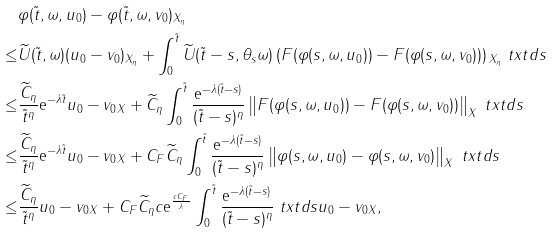Convert formula to latex. <formula><loc_0><loc_0><loc_500><loc_500>& \| \varphi ( \tilde { t } , \omega , u _ { 0 } ) - \varphi ( \tilde { t } , \omega , v _ { 0 } ) \| _ { X _ { \eta } } \\ \leq & \| \widetilde { U } ( \tilde { t } , \omega ) ( u _ { 0 } - v _ { 0 } ) \| _ { X _ { \eta } } + \int _ { 0 } ^ { \tilde { t } } \| \widetilde { U } ( \tilde { t } - s , \theta _ { s } \omega ) \left ( F ( \varphi ( s , \omega , u _ { 0 } ) ) - F ( \varphi ( s , \omega , v _ { 0 } ) ) \right ) \| _ { X _ { \eta } } \ t x t d s \\ \leq & \frac { \widetilde { C } _ { \eta } } { \tilde { t } ^ { \eta } } \text {e} ^ { - \lambda \tilde { t } } \| u _ { 0 } - v _ { 0 } \| _ { X } + \widetilde { C } _ { \eta } \int _ { 0 } ^ { \tilde { t } } \frac { \text {e} ^ { - \lambda ( \tilde { t } - s ) } } { ( \tilde { t } - s ) ^ { \eta } } \left \| F ( \varphi ( s , \omega , u _ { 0 } ) ) - F ( \varphi ( s , \omega , v _ { 0 } ) ) \right \| _ { X } \ t x t d s \\ \leq & \frac { \widetilde { C } _ { \eta } } { \tilde { t } ^ { \eta } } \text {e} ^ { - \lambda \tilde { t } } \| u _ { 0 } - v _ { 0 } \| _ { X } + C _ { F } \widetilde { C } _ { \eta } \int _ { 0 } ^ { \tilde { t } } \frac { \text {e} ^ { - \lambda ( \tilde { t } - s ) } } { ( \tilde { t } - s ) ^ { \eta } } \left \| \varphi ( s , \omega , u _ { 0 } ) - \varphi ( s , \omega , v _ { 0 } ) \right \| _ { X } \ t x t d s \\ \leq & \frac { \widetilde { C } _ { \eta } } { \tilde { t } ^ { \eta } } \| u _ { 0 } - v _ { 0 } \| _ { X } + C _ { F } \widetilde { C } _ { \eta } c \text {e} ^ { \frac { c C _ { F } } { \lambda } } \int _ { 0 } ^ { \tilde { t } } \frac { \text {e} ^ { - \lambda ( \tilde { t } - s ) } } { ( \tilde { t } - s ) ^ { \eta } } \ t x t d s \| u _ { 0 } - v _ { 0 } \| _ { X } ,</formula> 